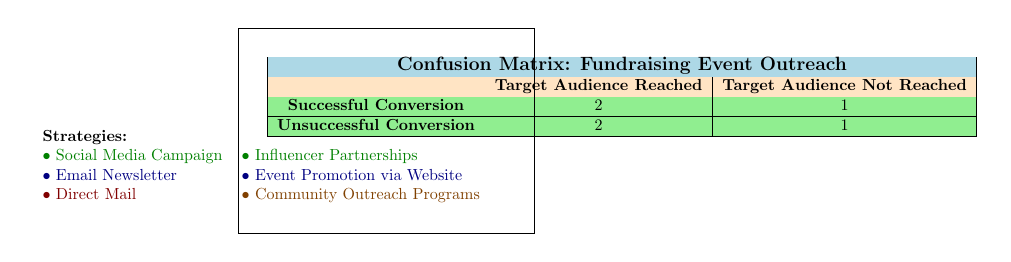What is the total number of strategies that successfully reached the target audience? There are two strategies that successfully reached the target audience: Social Media Campaign and Influencer Partnerships. We can find this by looking for the "Successful Conversion" row in the matrix and confirming those strategies in the list below.
Answer: 2 How many strategies failed to reach the target audience? The strategies that failed to reach the target audience are Direct Mail and Community Outreach Programs. We can count these by looking at the "Target Audience Not Reached" column in the matrix, which indicates two strategies fall under this category.
Answer: 2 What is the ratio of successful conversions to unsuccessful conversions? To find the ratio, we first identify the number of successful conversions (2) and unsuccessful conversions (2). The ratio of successful conversions to unsuccessful conversions is 2:2, which simplifies to 1:1.
Answer: 1:1 Did the Email Newsletter have a successful conversion? According to the table, the Email Newsletter reached the target audience but did not result in a successful conversion, as reflected in the "Unsuccessful Conversion" cell under the "Target Audience Reached" column.
Answer: No Which strategy had a successful conversion but did not reach the target audience? The only strategy that had a successful conversion without reaching the target audience is Community Outreach Programs. This can be determined by checking the "Unsuccessful Conversion" row that corresponds with "Target Audience Not Reached."
Answer: Community Outreach Programs How many strategies in total reached the target audience? To find this, we need to look at both successful and unsuccessful conversions under the "Target Audience Reached" category. Social Media Campaign, Email Newsletter, Influencer Partnerships, and Event Promotion via Website reached the target audience, totaling four strategies.
Answer: 4 Are there more successful conversions or unsuccessful conversions overall? The total number of successful conversions is 2, while the total number of unsuccessful conversions is also 2. Since the numbers are equal, there are not more successful conversions than unsuccessful ones.
Answer: No What percentage of the strategies that reached the target audience were successful conversions? To find the percentage, we take the number of successful conversions (2) and divide it by the total number of strategies that reached the target audience (4), then multiply by 100. (2/4) * 100 = 50%.
Answer: 50% 